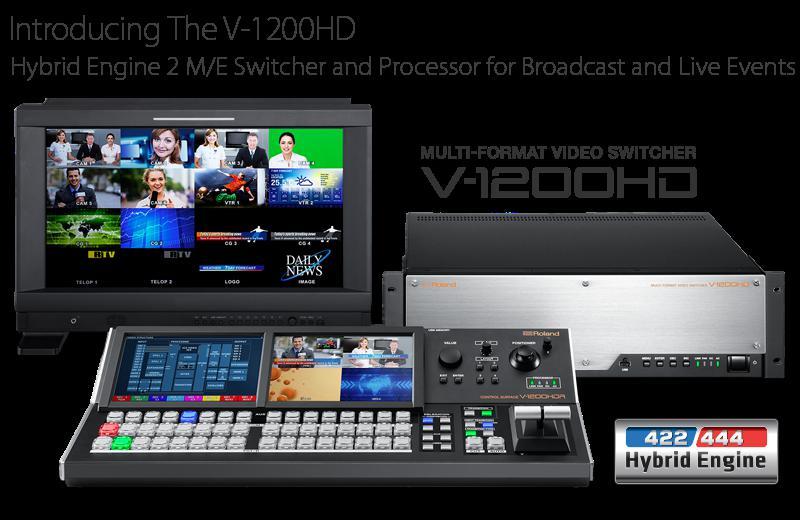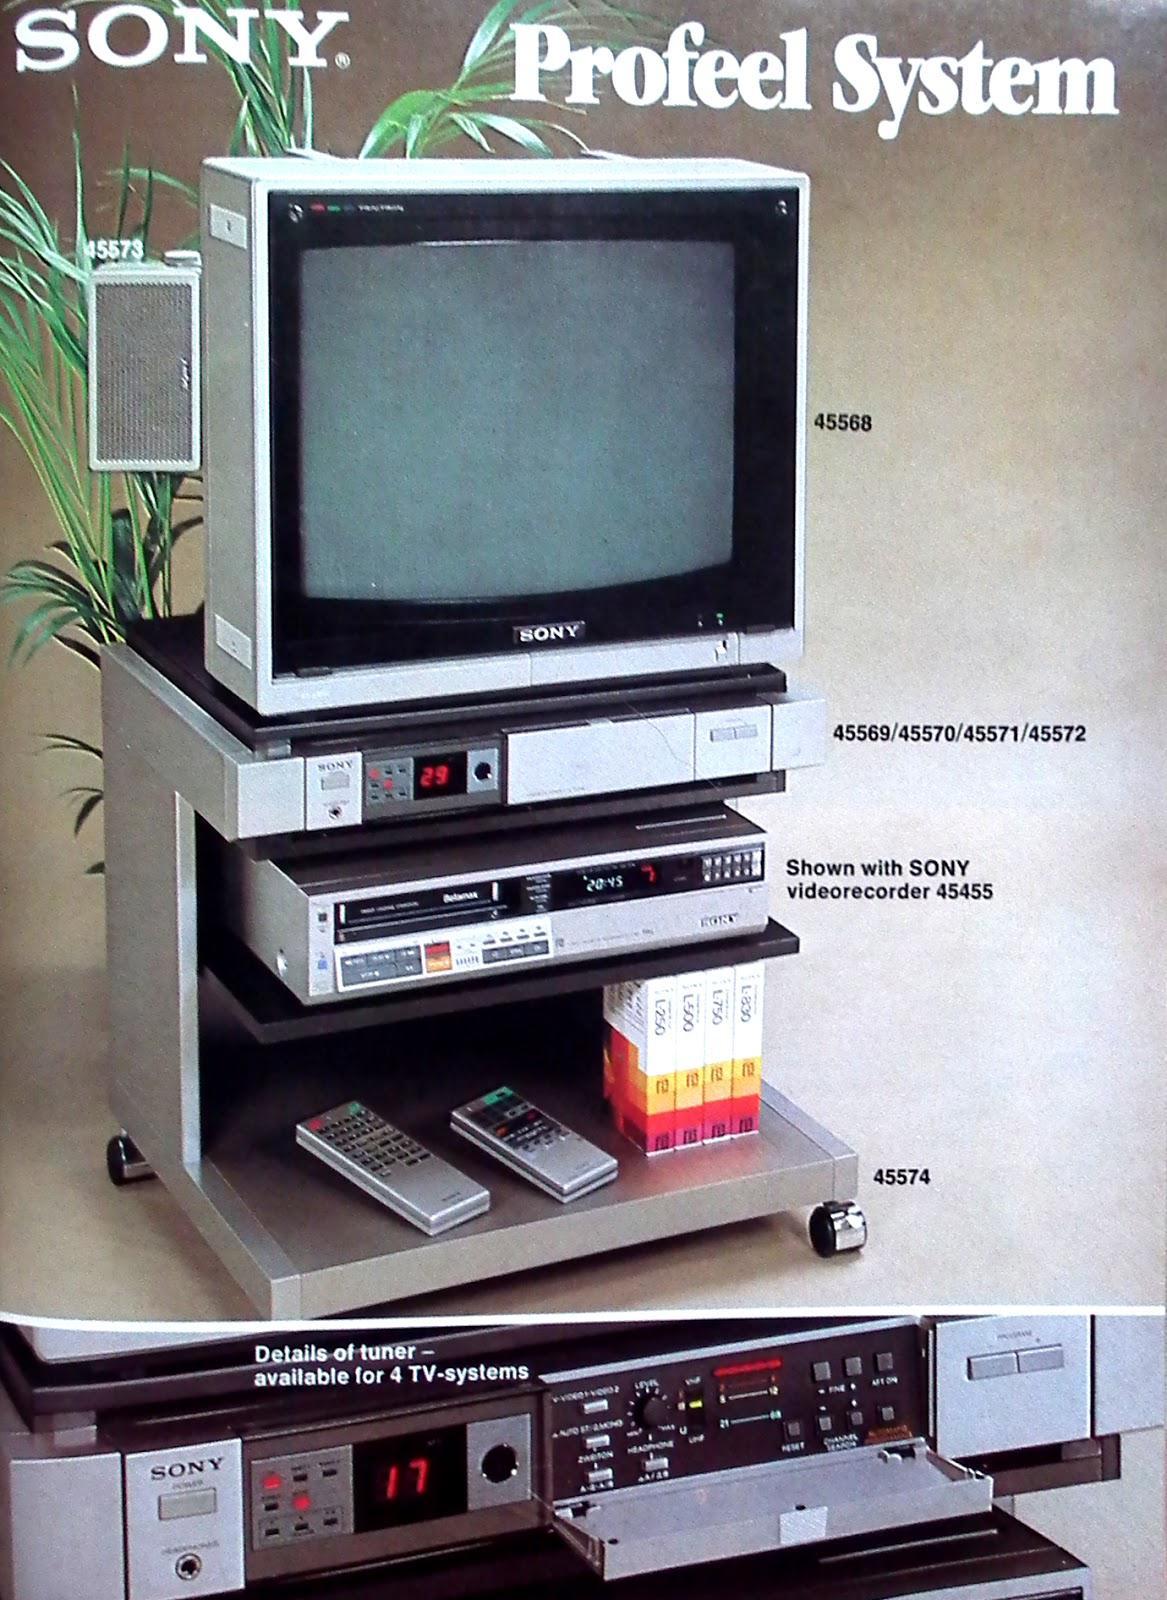The first image is the image on the left, the second image is the image on the right. Evaluate the accuracy of this statement regarding the images: "One of the images contains a VCR.". Is it true? Answer yes or no. Yes. 